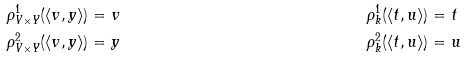<formula> <loc_0><loc_0><loc_500><loc_500>\rho ^ { 1 } _ { V \times Y } ( \langle v , y \rangle ) & = v & \rho ^ { 1 } _ { k } ( \langle t , u \rangle ) & = t \\ \rho ^ { 2 } _ { V \times Y } ( \langle v , y \rangle ) & = y & \rho ^ { 2 } _ { k } ( \langle t , u \rangle ) & = u</formula> 